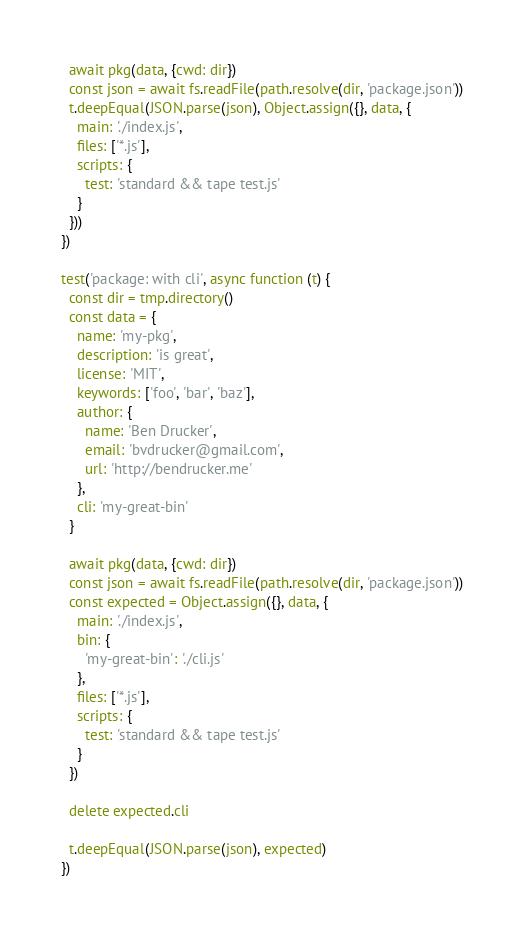<code> <loc_0><loc_0><loc_500><loc_500><_JavaScript_>  await pkg(data, {cwd: dir})
  const json = await fs.readFile(path.resolve(dir, 'package.json'))
  t.deepEqual(JSON.parse(json), Object.assign({}, data, {
    main: './index.js',
    files: ['*.js'],
    scripts: {
      test: 'standard && tape test.js'
    }
  }))
})

test('package: with cli', async function (t) {
  const dir = tmp.directory()
  const data = {
    name: 'my-pkg',
    description: 'is great',
    license: 'MIT',
    keywords: ['foo', 'bar', 'baz'],
    author: {
      name: 'Ben Drucker',
      email: 'bvdrucker@gmail.com',
      url: 'http://bendrucker.me'
    },
    cli: 'my-great-bin'
  }

  await pkg(data, {cwd: dir})
  const json = await fs.readFile(path.resolve(dir, 'package.json'))
  const expected = Object.assign({}, data, {
    main: './index.js',
    bin: {
      'my-great-bin': './cli.js'
    },
    files: ['*.js'],
    scripts: {
      test: 'standard && tape test.js'
    }
  })

  delete expected.cli

  t.deepEqual(JSON.parse(json), expected)
})
</code> 